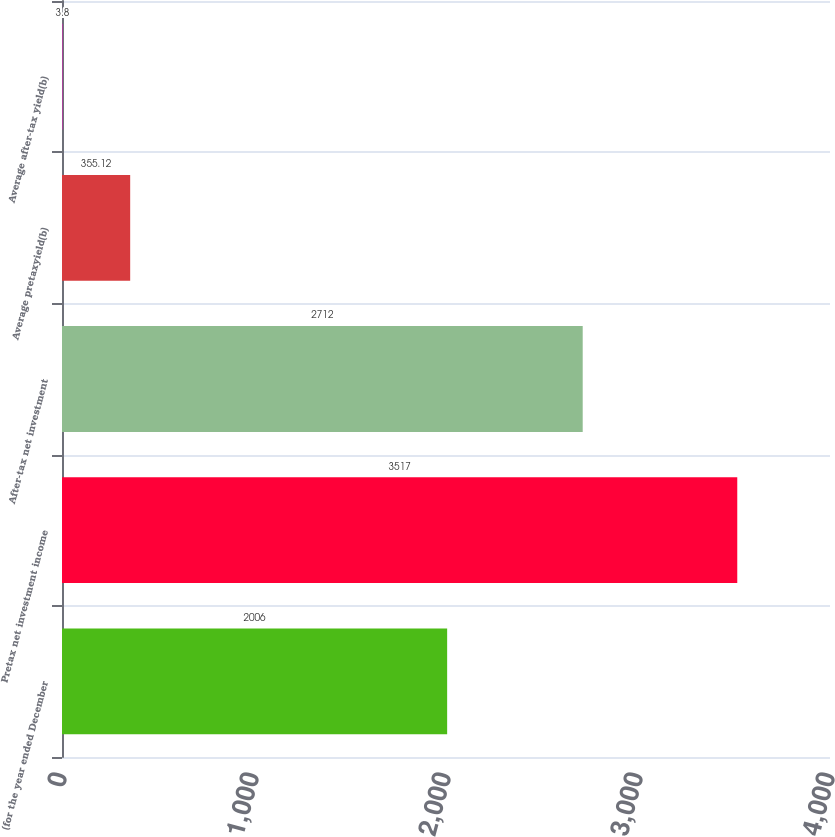Convert chart to OTSL. <chart><loc_0><loc_0><loc_500><loc_500><bar_chart><fcel>(for the year ended December<fcel>Pretax net investment income<fcel>After-tax net investment<fcel>Average pretaxyield(b)<fcel>Average after-tax yield(b)<nl><fcel>2006<fcel>3517<fcel>2712<fcel>355.12<fcel>3.8<nl></chart> 